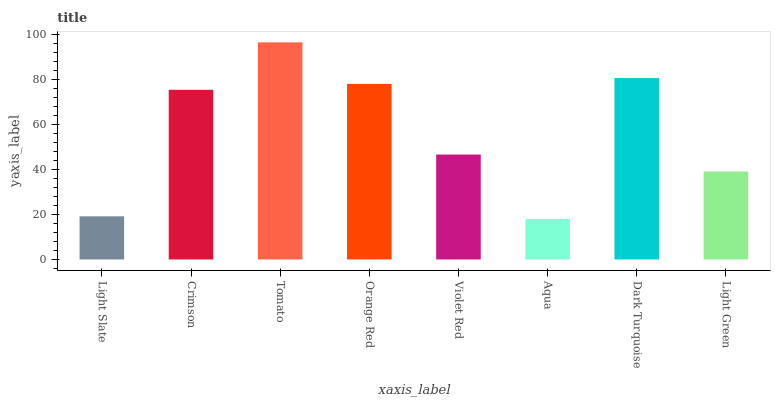Is Aqua the minimum?
Answer yes or no. Yes. Is Tomato the maximum?
Answer yes or no. Yes. Is Crimson the minimum?
Answer yes or no. No. Is Crimson the maximum?
Answer yes or no. No. Is Crimson greater than Light Slate?
Answer yes or no. Yes. Is Light Slate less than Crimson?
Answer yes or no. Yes. Is Light Slate greater than Crimson?
Answer yes or no. No. Is Crimson less than Light Slate?
Answer yes or no. No. Is Crimson the high median?
Answer yes or no. Yes. Is Violet Red the low median?
Answer yes or no. Yes. Is Tomato the high median?
Answer yes or no. No. Is Dark Turquoise the low median?
Answer yes or no. No. 